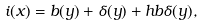Convert formula to latex. <formula><loc_0><loc_0><loc_500><loc_500>i ( x ) = b ( y ) + \delta ( y ) + h b \delta ( y ) ,</formula> 